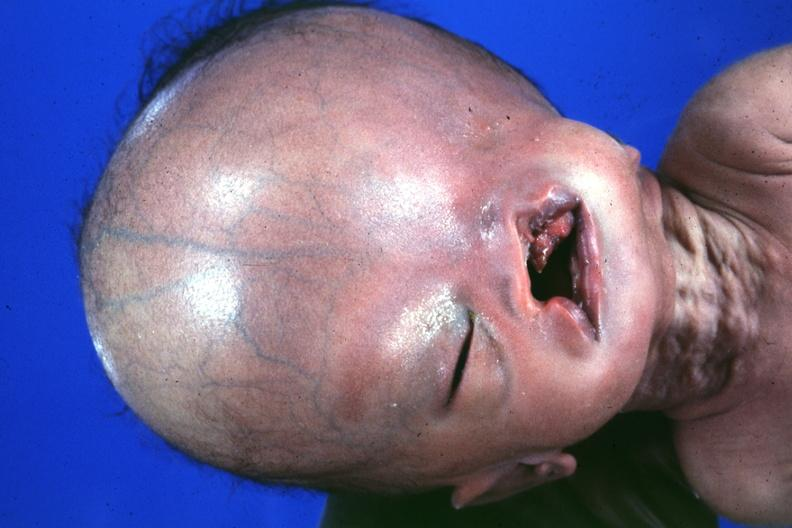does this image show absence of palpebral fissure cleft palate large head see protocol for details?
Answer the question using a single word or phrase. Yes 